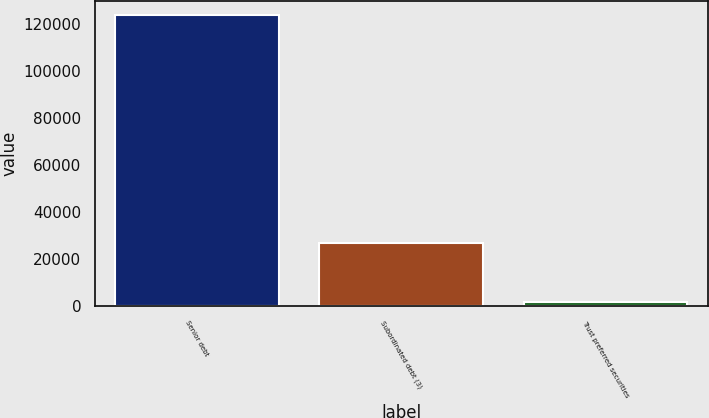Convert chart to OTSL. <chart><loc_0><loc_0><loc_500><loc_500><bar_chart><fcel>Senior debt<fcel>Subordinated debt (3)<fcel>Trust preferred securities<nl><fcel>123488<fcel>26963<fcel>1712<nl></chart> 